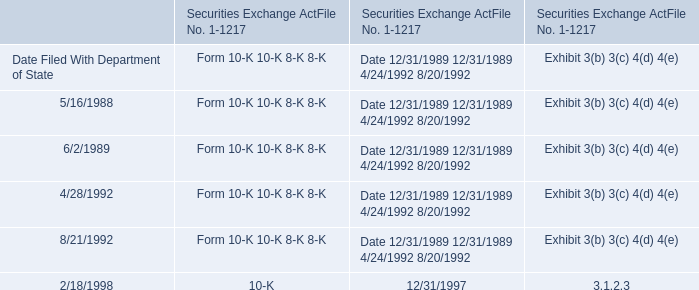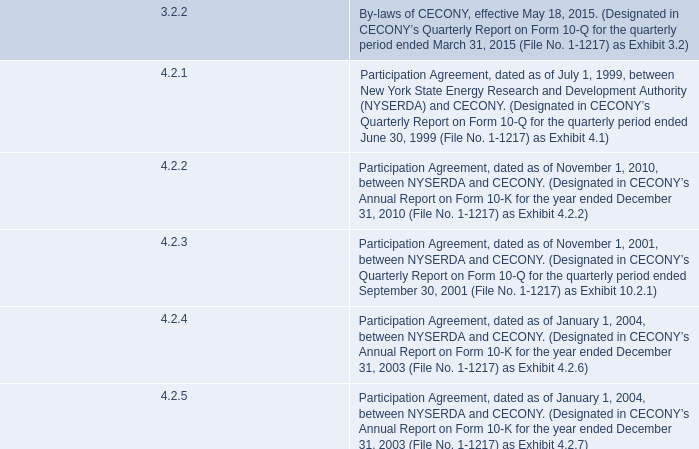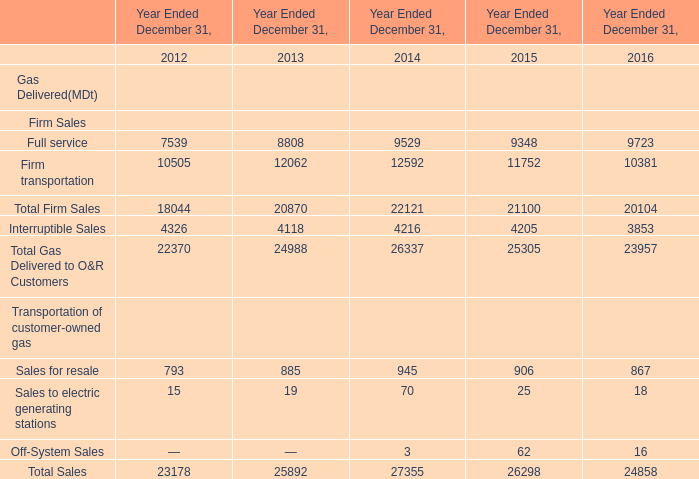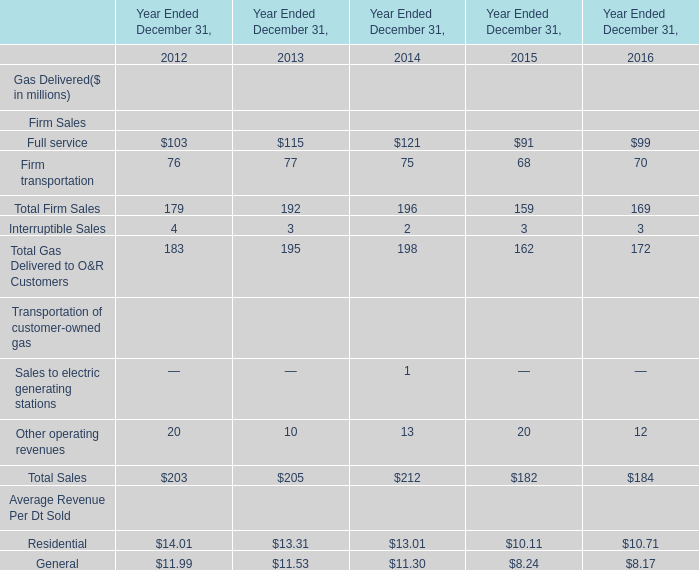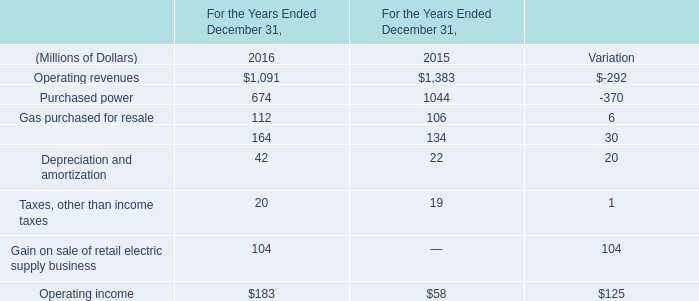What's the average of Purchased power of For the Years Ended December 31, 2015, and Interruptible Sales of Year Ended December 31, 2013 ? 
Computations: ((1044.0 + 4118.0) / 2)
Answer: 2581.0. 